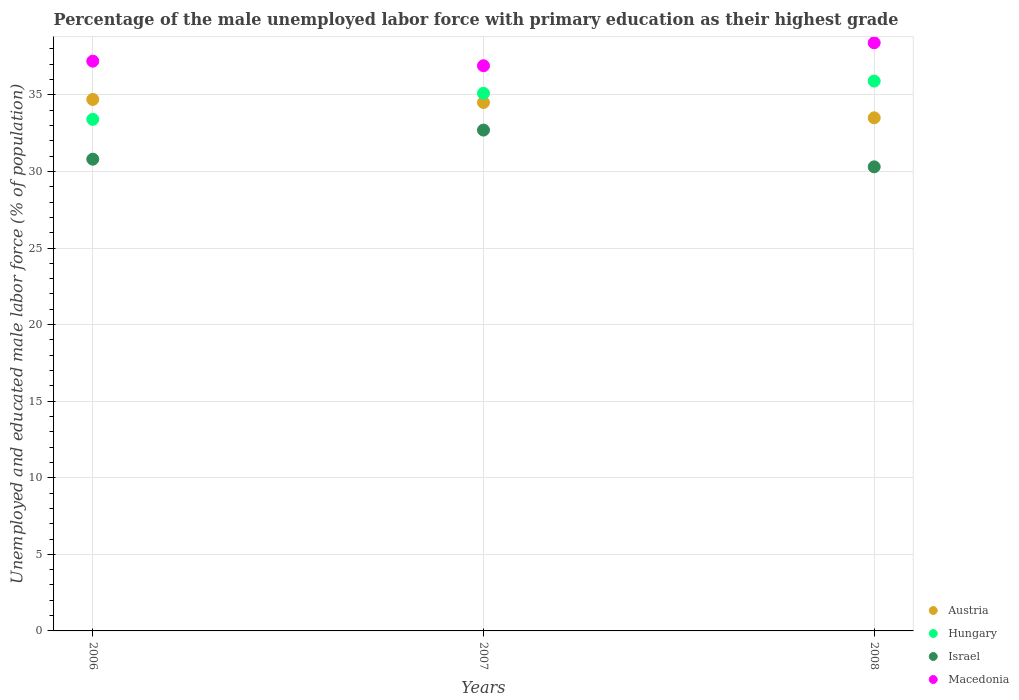Is the number of dotlines equal to the number of legend labels?
Offer a very short reply. Yes. What is the percentage of the unemployed male labor force with primary education in Macedonia in 2007?
Keep it short and to the point. 36.9. Across all years, what is the maximum percentage of the unemployed male labor force with primary education in Macedonia?
Your answer should be compact. 38.4. Across all years, what is the minimum percentage of the unemployed male labor force with primary education in Israel?
Offer a very short reply. 30.3. In which year was the percentage of the unemployed male labor force with primary education in Hungary minimum?
Your answer should be compact. 2006. What is the total percentage of the unemployed male labor force with primary education in Israel in the graph?
Offer a terse response. 93.8. What is the difference between the percentage of the unemployed male labor force with primary education in Austria in 2006 and that in 2008?
Make the answer very short. 1.2. What is the difference between the percentage of the unemployed male labor force with primary education in Israel in 2008 and the percentage of the unemployed male labor force with primary education in Hungary in 2007?
Keep it short and to the point. -4.8. What is the average percentage of the unemployed male labor force with primary education in Austria per year?
Keep it short and to the point. 34.23. In the year 2006, what is the difference between the percentage of the unemployed male labor force with primary education in Israel and percentage of the unemployed male labor force with primary education in Macedonia?
Provide a short and direct response. -6.4. What is the ratio of the percentage of the unemployed male labor force with primary education in Austria in 2006 to that in 2008?
Keep it short and to the point. 1.04. Is the percentage of the unemployed male labor force with primary education in Israel in 2006 less than that in 2007?
Your answer should be very brief. Yes. Is the difference between the percentage of the unemployed male labor force with primary education in Israel in 2007 and 2008 greater than the difference between the percentage of the unemployed male labor force with primary education in Macedonia in 2007 and 2008?
Ensure brevity in your answer.  Yes. What is the difference between the highest and the second highest percentage of the unemployed male labor force with primary education in Macedonia?
Provide a short and direct response. 1.2. What is the difference between the highest and the lowest percentage of the unemployed male labor force with primary education in Hungary?
Ensure brevity in your answer.  2.5. In how many years, is the percentage of the unemployed male labor force with primary education in Hungary greater than the average percentage of the unemployed male labor force with primary education in Hungary taken over all years?
Provide a succinct answer. 2. Is the sum of the percentage of the unemployed male labor force with primary education in Hungary in 2007 and 2008 greater than the maximum percentage of the unemployed male labor force with primary education in Austria across all years?
Give a very brief answer. Yes. Is it the case that in every year, the sum of the percentage of the unemployed male labor force with primary education in Hungary and percentage of the unemployed male labor force with primary education in Austria  is greater than the sum of percentage of the unemployed male labor force with primary education in Macedonia and percentage of the unemployed male labor force with primary education in Israel?
Make the answer very short. No. Is the percentage of the unemployed male labor force with primary education in Austria strictly greater than the percentage of the unemployed male labor force with primary education in Hungary over the years?
Ensure brevity in your answer.  No. Is the percentage of the unemployed male labor force with primary education in Austria strictly less than the percentage of the unemployed male labor force with primary education in Israel over the years?
Your response must be concise. No. How many dotlines are there?
Your answer should be very brief. 4. How many years are there in the graph?
Your response must be concise. 3. Are the values on the major ticks of Y-axis written in scientific E-notation?
Your response must be concise. No. Where does the legend appear in the graph?
Provide a short and direct response. Bottom right. How are the legend labels stacked?
Keep it short and to the point. Vertical. What is the title of the graph?
Provide a succinct answer. Percentage of the male unemployed labor force with primary education as their highest grade. Does "Middle income" appear as one of the legend labels in the graph?
Your answer should be compact. No. What is the label or title of the X-axis?
Provide a short and direct response. Years. What is the label or title of the Y-axis?
Your answer should be compact. Unemployed and educated male labor force (% of population). What is the Unemployed and educated male labor force (% of population) of Austria in 2006?
Offer a terse response. 34.7. What is the Unemployed and educated male labor force (% of population) in Hungary in 2006?
Ensure brevity in your answer.  33.4. What is the Unemployed and educated male labor force (% of population) in Israel in 2006?
Give a very brief answer. 30.8. What is the Unemployed and educated male labor force (% of population) of Macedonia in 2006?
Ensure brevity in your answer.  37.2. What is the Unemployed and educated male labor force (% of population) of Austria in 2007?
Ensure brevity in your answer.  34.5. What is the Unemployed and educated male labor force (% of population) of Hungary in 2007?
Offer a terse response. 35.1. What is the Unemployed and educated male labor force (% of population) of Israel in 2007?
Your answer should be compact. 32.7. What is the Unemployed and educated male labor force (% of population) of Macedonia in 2007?
Provide a short and direct response. 36.9. What is the Unemployed and educated male labor force (% of population) of Austria in 2008?
Provide a succinct answer. 33.5. What is the Unemployed and educated male labor force (% of population) of Hungary in 2008?
Make the answer very short. 35.9. What is the Unemployed and educated male labor force (% of population) of Israel in 2008?
Your answer should be compact. 30.3. What is the Unemployed and educated male labor force (% of population) in Macedonia in 2008?
Make the answer very short. 38.4. Across all years, what is the maximum Unemployed and educated male labor force (% of population) of Austria?
Offer a terse response. 34.7. Across all years, what is the maximum Unemployed and educated male labor force (% of population) in Hungary?
Your answer should be very brief. 35.9. Across all years, what is the maximum Unemployed and educated male labor force (% of population) of Israel?
Ensure brevity in your answer.  32.7. Across all years, what is the maximum Unemployed and educated male labor force (% of population) of Macedonia?
Ensure brevity in your answer.  38.4. Across all years, what is the minimum Unemployed and educated male labor force (% of population) of Austria?
Provide a short and direct response. 33.5. Across all years, what is the minimum Unemployed and educated male labor force (% of population) of Hungary?
Provide a short and direct response. 33.4. Across all years, what is the minimum Unemployed and educated male labor force (% of population) of Israel?
Offer a terse response. 30.3. Across all years, what is the minimum Unemployed and educated male labor force (% of population) in Macedonia?
Keep it short and to the point. 36.9. What is the total Unemployed and educated male labor force (% of population) in Austria in the graph?
Your answer should be compact. 102.7. What is the total Unemployed and educated male labor force (% of population) of Hungary in the graph?
Provide a succinct answer. 104.4. What is the total Unemployed and educated male labor force (% of population) in Israel in the graph?
Offer a very short reply. 93.8. What is the total Unemployed and educated male labor force (% of population) in Macedonia in the graph?
Your answer should be very brief. 112.5. What is the difference between the Unemployed and educated male labor force (% of population) in Austria in 2006 and that in 2007?
Offer a terse response. 0.2. What is the difference between the Unemployed and educated male labor force (% of population) in Israel in 2006 and that in 2007?
Keep it short and to the point. -1.9. What is the difference between the Unemployed and educated male labor force (% of population) in Austria in 2006 and that in 2008?
Offer a terse response. 1.2. What is the difference between the Unemployed and educated male labor force (% of population) of Macedonia in 2006 and that in 2008?
Provide a succinct answer. -1.2. What is the difference between the Unemployed and educated male labor force (% of population) in Austria in 2007 and that in 2008?
Offer a very short reply. 1. What is the difference between the Unemployed and educated male labor force (% of population) in Macedonia in 2007 and that in 2008?
Keep it short and to the point. -1.5. What is the difference between the Unemployed and educated male labor force (% of population) in Austria in 2006 and the Unemployed and educated male labor force (% of population) in Hungary in 2007?
Your response must be concise. -0.4. What is the difference between the Unemployed and educated male labor force (% of population) in Austria in 2006 and the Unemployed and educated male labor force (% of population) in Macedonia in 2007?
Provide a short and direct response. -2.2. What is the difference between the Unemployed and educated male labor force (% of population) of Hungary in 2006 and the Unemployed and educated male labor force (% of population) of Israel in 2007?
Make the answer very short. 0.7. What is the difference between the Unemployed and educated male labor force (% of population) of Austria in 2006 and the Unemployed and educated male labor force (% of population) of Hungary in 2008?
Ensure brevity in your answer.  -1.2. What is the difference between the Unemployed and educated male labor force (% of population) in Austria in 2006 and the Unemployed and educated male labor force (% of population) in Israel in 2008?
Ensure brevity in your answer.  4.4. What is the difference between the Unemployed and educated male labor force (% of population) in Hungary in 2006 and the Unemployed and educated male labor force (% of population) in Israel in 2008?
Your answer should be compact. 3.1. What is the difference between the Unemployed and educated male labor force (% of population) of Hungary in 2006 and the Unemployed and educated male labor force (% of population) of Macedonia in 2008?
Offer a terse response. -5. What is the difference between the Unemployed and educated male labor force (% of population) of Austria in 2007 and the Unemployed and educated male labor force (% of population) of Macedonia in 2008?
Make the answer very short. -3.9. What is the difference between the Unemployed and educated male labor force (% of population) of Hungary in 2007 and the Unemployed and educated male labor force (% of population) of Israel in 2008?
Give a very brief answer. 4.8. What is the difference between the Unemployed and educated male labor force (% of population) in Hungary in 2007 and the Unemployed and educated male labor force (% of population) in Macedonia in 2008?
Offer a terse response. -3.3. What is the average Unemployed and educated male labor force (% of population) of Austria per year?
Give a very brief answer. 34.23. What is the average Unemployed and educated male labor force (% of population) in Hungary per year?
Make the answer very short. 34.8. What is the average Unemployed and educated male labor force (% of population) of Israel per year?
Make the answer very short. 31.27. What is the average Unemployed and educated male labor force (% of population) of Macedonia per year?
Ensure brevity in your answer.  37.5. In the year 2006, what is the difference between the Unemployed and educated male labor force (% of population) in Austria and Unemployed and educated male labor force (% of population) in Hungary?
Ensure brevity in your answer.  1.3. In the year 2006, what is the difference between the Unemployed and educated male labor force (% of population) of Austria and Unemployed and educated male labor force (% of population) of Macedonia?
Your answer should be very brief. -2.5. In the year 2006, what is the difference between the Unemployed and educated male labor force (% of population) in Hungary and Unemployed and educated male labor force (% of population) in Israel?
Keep it short and to the point. 2.6. In the year 2006, what is the difference between the Unemployed and educated male labor force (% of population) in Israel and Unemployed and educated male labor force (% of population) in Macedonia?
Give a very brief answer. -6.4. In the year 2007, what is the difference between the Unemployed and educated male labor force (% of population) in Hungary and Unemployed and educated male labor force (% of population) in Macedonia?
Offer a terse response. -1.8. In the year 2007, what is the difference between the Unemployed and educated male labor force (% of population) in Israel and Unemployed and educated male labor force (% of population) in Macedonia?
Offer a very short reply. -4.2. In the year 2008, what is the difference between the Unemployed and educated male labor force (% of population) in Israel and Unemployed and educated male labor force (% of population) in Macedonia?
Offer a very short reply. -8.1. What is the ratio of the Unemployed and educated male labor force (% of population) in Austria in 2006 to that in 2007?
Ensure brevity in your answer.  1.01. What is the ratio of the Unemployed and educated male labor force (% of population) of Hungary in 2006 to that in 2007?
Your answer should be very brief. 0.95. What is the ratio of the Unemployed and educated male labor force (% of population) in Israel in 2006 to that in 2007?
Provide a succinct answer. 0.94. What is the ratio of the Unemployed and educated male labor force (% of population) of Macedonia in 2006 to that in 2007?
Provide a short and direct response. 1.01. What is the ratio of the Unemployed and educated male labor force (% of population) in Austria in 2006 to that in 2008?
Provide a short and direct response. 1.04. What is the ratio of the Unemployed and educated male labor force (% of population) in Hungary in 2006 to that in 2008?
Provide a short and direct response. 0.93. What is the ratio of the Unemployed and educated male labor force (% of population) in Israel in 2006 to that in 2008?
Provide a succinct answer. 1.02. What is the ratio of the Unemployed and educated male labor force (% of population) in Macedonia in 2006 to that in 2008?
Your answer should be very brief. 0.97. What is the ratio of the Unemployed and educated male labor force (% of population) of Austria in 2007 to that in 2008?
Provide a short and direct response. 1.03. What is the ratio of the Unemployed and educated male labor force (% of population) of Hungary in 2007 to that in 2008?
Your answer should be very brief. 0.98. What is the ratio of the Unemployed and educated male labor force (% of population) in Israel in 2007 to that in 2008?
Your answer should be very brief. 1.08. What is the ratio of the Unemployed and educated male labor force (% of population) of Macedonia in 2007 to that in 2008?
Your answer should be compact. 0.96. What is the difference between the highest and the second highest Unemployed and educated male labor force (% of population) in Israel?
Give a very brief answer. 1.9. What is the difference between the highest and the lowest Unemployed and educated male labor force (% of population) of Austria?
Your answer should be very brief. 1.2. What is the difference between the highest and the lowest Unemployed and educated male labor force (% of population) in Hungary?
Your response must be concise. 2.5. What is the difference between the highest and the lowest Unemployed and educated male labor force (% of population) of Israel?
Provide a succinct answer. 2.4. What is the difference between the highest and the lowest Unemployed and educated male labor force (% of population) of Macedonia?
Offer a very short reply. 1.5. 